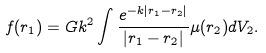Convert formula to latex. <formula><loc_0><loc_0><loc_500><loc_500>f ( { r } _ { 1 } ) = G k ^ { 2 } \int \frac { e ^ { - k \left | { r } _ { 1 } - { r } _ { 2 } \right | } } { \left | { r } _ { 1 } - { r } _ { 2 } \right | } \mu ( { r } _ { 2 } ) d V _ { 2 } .</formula> 